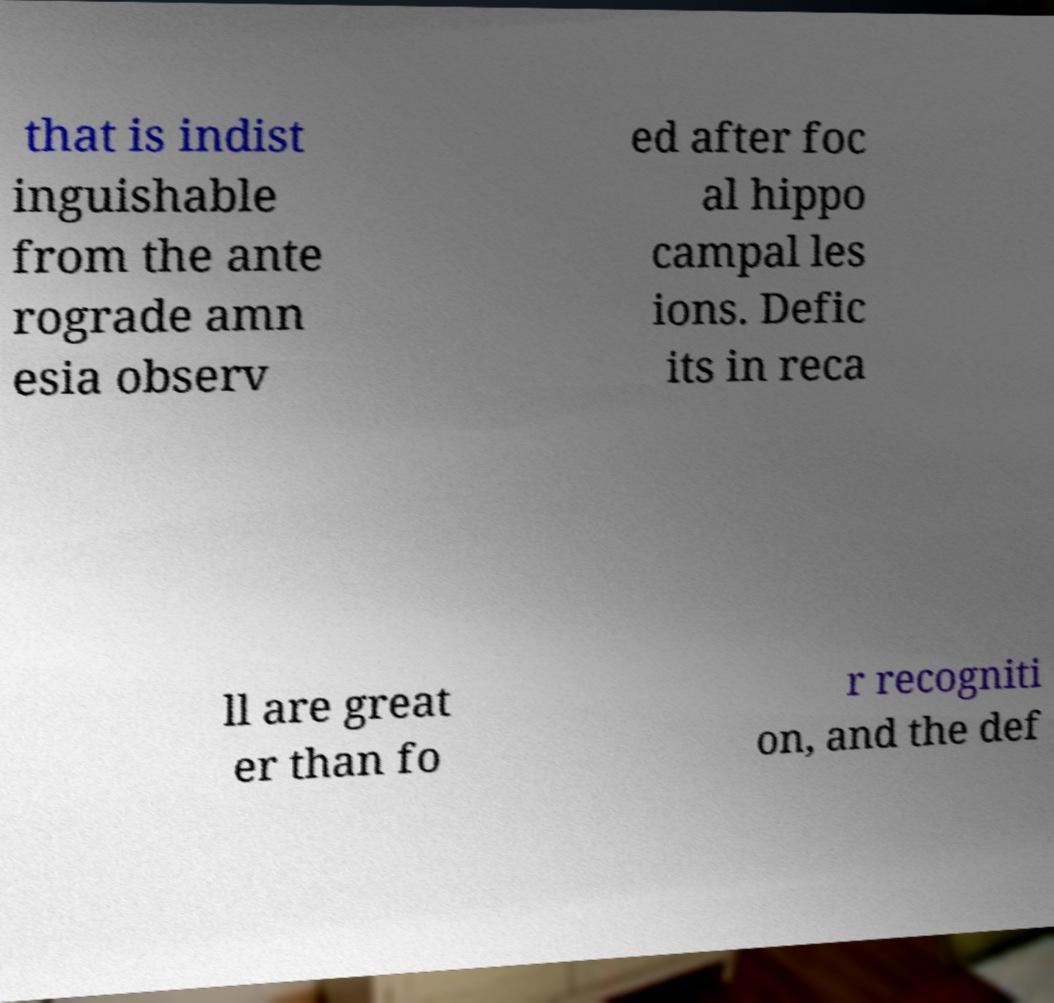Can you accurately transcribe the text from the provided image for me? that is indist inguishable from the ante rograde amn esia observ ed after foc al hippo campal les ions. Defic its in reca ll are great er than fo r recogniti on, and the def 